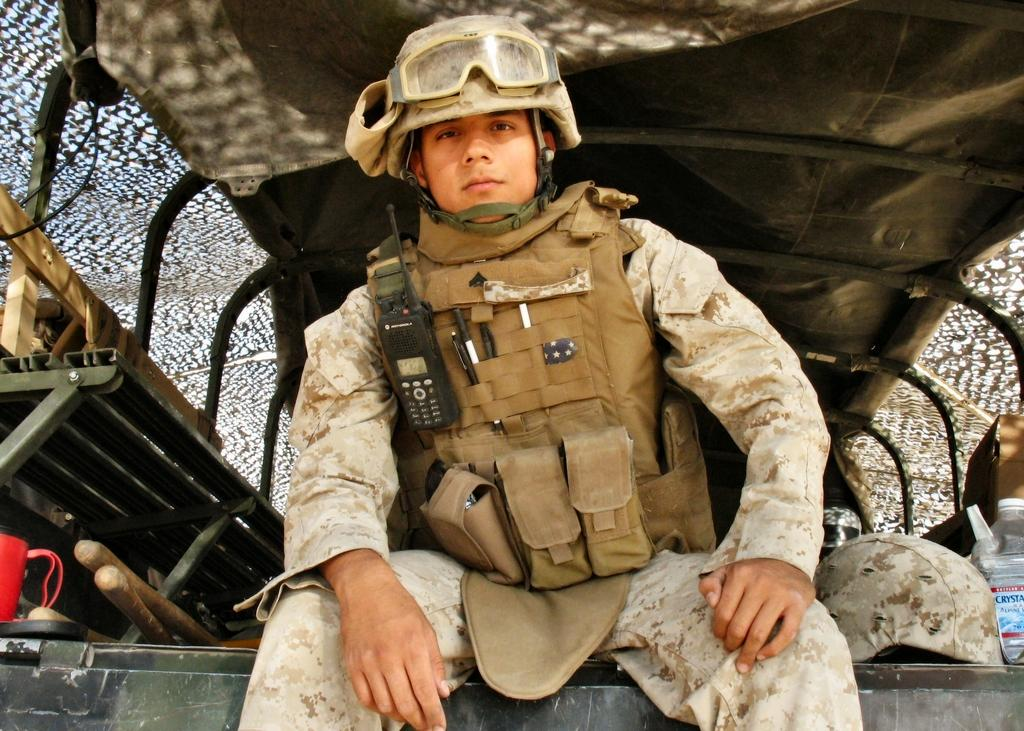What is the person in the image doing? The person is sitting in a vehicle. What type of headwear is visible in the image? There is a cap visible in the image. What can be seen for hydration purposes in the image? There is a water bottle in the image. Can you describe any other objects present in the image? There are other objects present in the image, but their specific details are not mentioned in the provided facts. Are there any cobwebs visible in the image? There is no mention of cobwebs in the provided facts, so it cannot be determined if any are present in the image. 